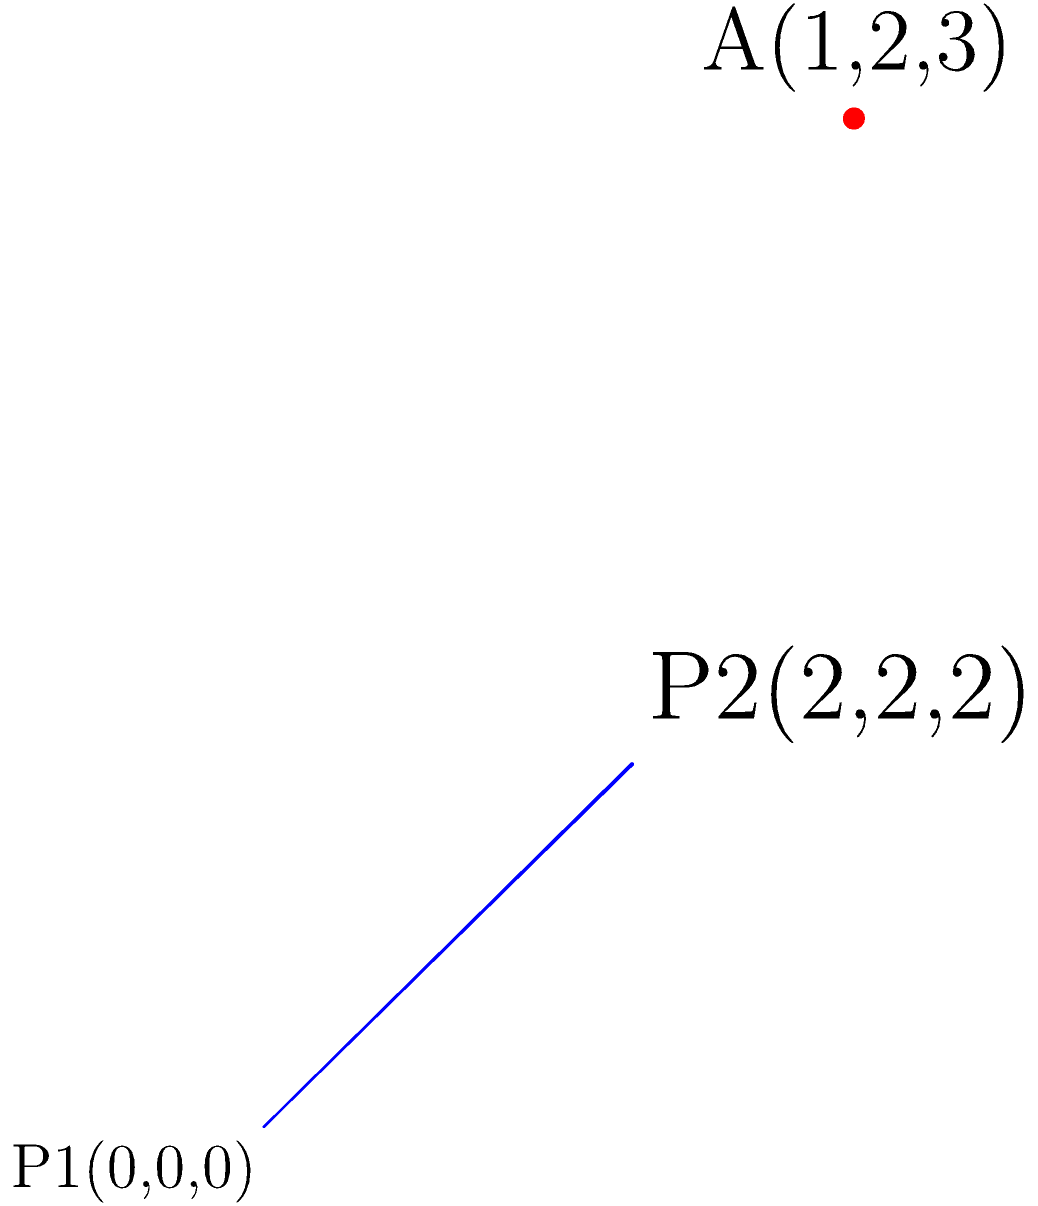In the 3D coordinate system shown above, point $A$ has coordinates $(1,2,3)$, and a line passes through points $P_1(0,0,0)$ and $P_2(2,2,2)$. Calculate the shortest distance between point $A$ and the line. To find the shortest distance between a point and a line in 3D space, we can use the formula:

$$d = \frac{|\vec{v} \times \vec{PA}|}{|\vec{v}|}$$

Where $\vec{v}$ is the direction vector of the line, and $\vec{PA}$ is the vector from any point on the line to point $A$.

Step 1: Find the direction vector $\vec{v}$ of the line:
$\vec{v} = P_2 - P_1 = (2,2,2) - (0,0,0) = (2,2,2)$

Step 2: Find vector $\vec{PA}$:
$\vec{PA} = A - P_1 = (1,2,3) - (0,0,0) = (1,2,3)$

Step 3: Calculate the cross product $\vec{v} \times \vec{PA}$:
$\vec{v} \times \vec{PA} = (2,2,2) \times (1,2,3) = (2 \cdot 3 - 2 \cdot 2, 2 \cdot 1 - 2 \cdot 3, 2 \cdot 2 - 2 \cdot 1) = (2, -4, 2)$

Step 4: Calculate the magnitude of the cross product:
$|\vec{v} \times \vec{PA}| = \sqrt{2^2 + (-4)^2 + 2^2} = \sqrt{24} = 2\sqrt{6}$

Step 5: Calculate the magnitude of $\vec{v}$:
$|\vec{v}| = \sqrt{2^2 + 2^2 + 2^2} = 2\sqrt{3}$

Step 6: Apply the formula to find the shortest distance:
$$d = \frac{|\vec{v} \times \vec{PA}|}{|\vec{v}|} = \frac{2\sqrt{6}}{2\sqrt{3}} = \frac{\sqrt{2}}{\sqrt{1}} = \sqrt{2}$$

Therefore, the shortest distance between point $A$ and the line is $\sqrt{2}$ units.
Answer: $\sqrt{2}$ units 